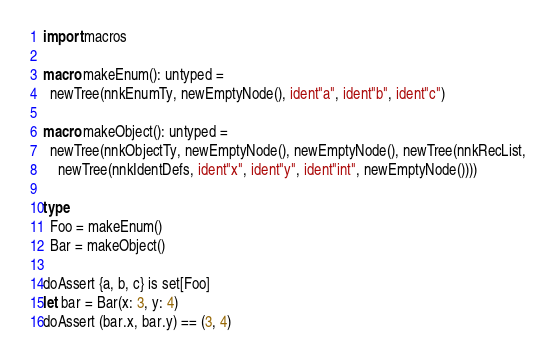Convert code to text. <code><loc_0><loc_0><loc_500><loc_500><_Nim_>import macros

macro makeEnum(): untyped =
  newTree(nnkEnumTy, newEmptyNode(), ident"a", ident"b", ident"c")

macro makeObject(): untyped =
  newTree(nnkObjectTy, newEmptyNode(), newEmptyNode(), newTree(nnkRecList,
    newTree(nnkIdentDefs, ident"x", ident"y", ident"int", newEmptyNode())))

type
  Foo = makeEnum()
  Bar = makeObject()

doAssert {a, b, c} is set[Foo]
let bar = Bar(x: 3, y: 4)
doAssert (bar.x, bar.y) == (3, 4)
</code> 